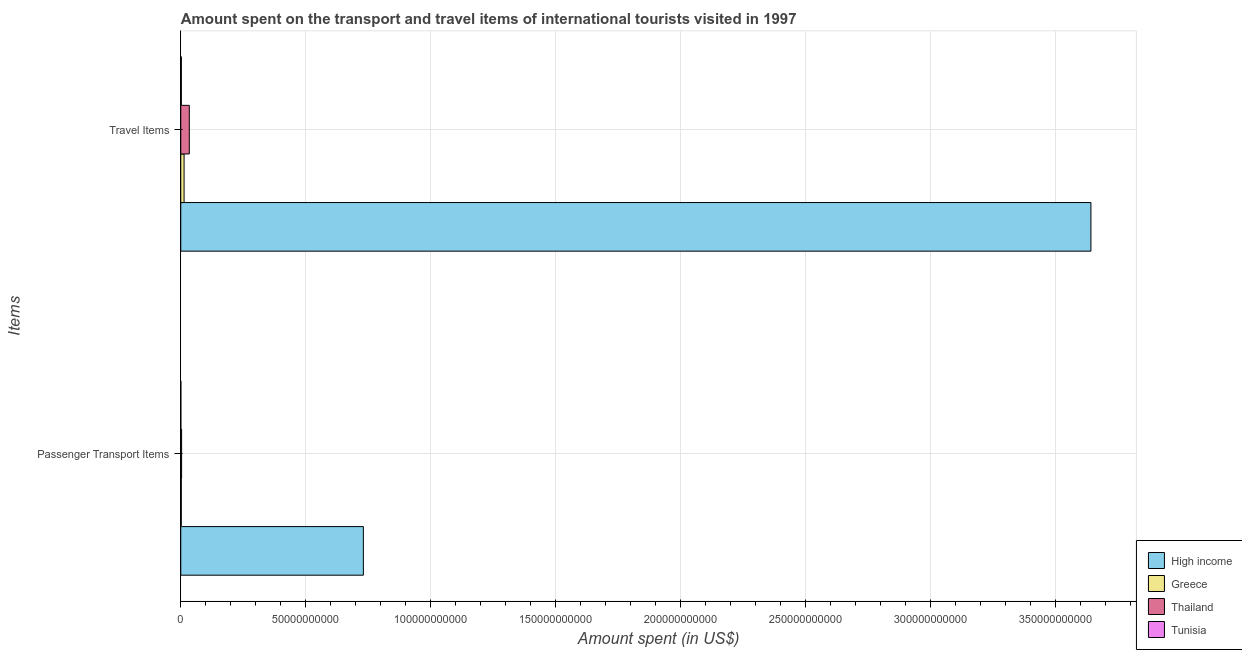Are the number of bars on each tick of the Y-axis equal?
Give a very brief answer. Yes. How many bars are there on the 1st tick from the top?
Your response must be concise. 4. How many bars are there on the 2nd tick from the bottom?
Your answer should be compact. 4. What is the label of the 2nd group of bars from the top?
Ensure brevity in your answer.  Passenger Transport Items. What is the amount spent on passenger transport items in Thailand?
Give a very brief answer. 3.36e+08. Across all countries, what is the maximum amount spent in travel items?
Keep it short and to the point. 3.64e+11. Across all countries, what is the minimum amount spent in travel items?
Your answer should be compact. 2.35e+08. In which country was the amount spent on passenger transport items maximum?
Ensure brevity in your answer.  High income. In which country was the amount spent on passenger transport items minimum?
Your answer should be very brief. Tunisia. What is the total amount spent on passenger transport items in the graph?
Offer a very short reply. 7.36e+1. What is the difference between the amount spent on passenger transport items in Thailand and that in Greece?
Give a very brief answer. 1.26e+08. What is the difference between the amount spent on passenger transport items in Tunisia and the amount spent in travel items in High income?
Keep it short and to the point. -3.64e+11. What is the average amount spent on passenger transport items per country?
Provide a short and direct response. 1.84e+1. What is the difference between the amount spent on passenger transport items and amount spent in travel items in High income?
Your answer should be compact. -2.91e+11. What is the ratio of the amount spent on passenger transport items in Thailand to that in Tunisia?
Provide a short and direct response. 10.84. What does the 1st bar from the top in Travel Items represents?
Keep it short and to the point. Tunisia. How many bars are there?
Ensure brevity in your answer.  8. How many countries are there in the graph?
Offer a terse response. 4. Are the values on the major ticks of X-axis written in scientific E-notation?
Ensure brevity in your answer.  No. Does the graph contain any zero values?
Offer a terse response. No. Does the graph contain grids?
Your response must be concise. Yes. How are the legend labels stacked?
Make the answer very short. Vertical. What is the title of the graph?
Your answer should be very brief. Amount spent on the transport and travel items of international tourists visited in 1997. What is the label or title of the X-axis?
Keep it short and to the point. Amount spent (in US$). What is the label or title of the Y-axis?
Your response must be concise. Items. What is the Amount spent (in US$) in High income in Passenger Transport Items?
Your answer should be compact. 7.31e+1. What is the Amount spent (in US$) in Greece in Passenger Transport Items?
Provide a succinct answer. 2.10e+08. What is the Amount spent (in US$) in Thailand in Passenger Transport Items?
Offer a very short reply. 3.36e+08. What is the Amount spent (in US$) in Tunisia in Passenger Transport Items?
Offer a terse response. 3.10e+07. What is the Amount spent (in US$) in High income in Travel Items?
Make the answer very short. 3.64e+11. What is the Amount spent (in US$) in Greece in Travel Items?
Your response must be concise. 1.33e+09. What is the Amount spent (in US$) in Thailand in Travel Items?
Ensure brevity in your answer.  3.42e+09. What is the Amount spent (in US$) in Tunisia in Travel Items?
Your response must be concise. 2.35e+08. Across all Items, what is the maximum Amount spent (in US$) in High income?
Provide a succinct answer. 3.64e+11. Across all Items, what is the maximum Amount spent (in US$) in Greece?
Ensure brevity in your answer.  1.33e+09. Across all Items, what is the maximum Amount spent (in US$) in Thailand?
Provide a succinct answer. 3.42e+09. Across all Items, what is the maximum Amount spent (in US$) of Tunisia?
Make the answer very short. 2.35e+08. Across all Items, what is the minimum Amount spent (in US$) in High income?
Your response must be concise. 7.31e+1. Across all Items, what is the minimum Amount spent (in US$) in Greece?
Your answer should be compact. 2.10e+08. Across all Items, what is the minimum Amount spent (in US$) in Thailand?
Provide a short and direct response. 3.36e+08. Across all Items, what is the minimum Amount spent (in US$) in Tunisia?
Make the answer very short. 3.10e+07. What is the total Amount spent (in US$) of High income in the graph?
Make the answer very short. 4.37e+11. What is the total Amount spent (in US$) in Greece in the graph?
Give a very brief answer. 1.54e+09. What is the total Amount spent (in US$) in Thailand in the graph?
Provide a short and direct response. 3.75e+09. What is the total Amount spent (in US$) in Tunisia in the graph?
Give a very brief answer. 2.66e+08. What is the difference between the Amount spent (in US$) of High income in Passenger Transport Items and that in Travel Items?
Make the answer very short. -2.91e+11. What is the difference between the Amount spent (in US$) of Greece in Passenger Transport Items and that in Travel Items?
Ensure brevity in your answer.  -1.12e+09. What is the difference between the Amount spent (in US$) in Thailand in Passenger Transport Items and that in Travel Items?
Your answer should be compact. -3.08e+09. What is the difference between the Amount spent (in US$) in Tunisia in Passenger Transport Items and that in Travel Items?
Your answer should be very brief. -2.04e+08. What is the difference between the Amount spent (in US$) of High income in Passenger Transport Items and the Amount spent (in US$) of Greece in Travel Items?
Give a very brief answer. 7.17e+1. What is the difference between the Amount spent (in US$) of High income in Passenger Transport Items and the Amount spent (in US$) of Thailand in Travel Items?
Offer a terse response. 6.96e+1. What is the difference between the Amount spent (in US$) of High income in Passenger Transport Items and the Amount spent (in US$) of Tunisia in Travel Items?
Your answer should be very brief. 7.28e+1. What is the difference between the Amount spent (in US$) of Greece in Passenger Transport Items and the Amount spent (in US$) of Thailand in Travel Items?
Offer a terse response. -3.21e+09. What is the difference between the Amount spent (in US$) in Greece in Passenger Transport Items and the Amount spent (in US$) in Tunisia in Travel Items?
Your response must be concise. -2.50e+07. What is the difference between the Amount spent (in US$) of Thailand in Passenger Transport Items and the Amount spent (in US$) of Tunisia in Travel Items?
Your answer should be very brief. 1.01e+08. What is the average Amount spent (in US$) in High income per Items?
Your answer should be compact. 2.19e+11. What is the average Amount spent (in US$) of Greece per Items?
Give a very brief answer. 7.68e+08. What is the average Amount spent (in US$) in Thailand per Items?
Your answer should be compact. 1.88e+09. What is the average Amount spent (in US$) of Tunisia per Items?
Your answer should be very brief. 1.33e+08. What is the difference between the Amount spent (in US$) of High income and Amount spent (in US$) of Greece in Passenger Transport Items?
Give a very brief answer. 7.28e+1. What is the difference between the Amount spent (in US$) of High income and Amount spent (in US$) of Thailand in Passenger Transport Items?
Your answer should be very brief. 7.27e+1. What is the difference between the Amount spent (in US$) of High income and Amount spent (in US$) of Tunisia in Passenger Transport Items?
Offer a very short reply. 7.30e+1. What is the difference between the Amount spent (in US$) of Greece and Amount spent (in US$) of Thailand in Passenger Transport Items?
Your answer should be compact. -1.26e+08. What is the difference between the Amount spent (in US$) of Greece and Amount spent (in US$) of Tunisia in Passenger Transport Items?
Ensure brevity in your answer.  1.79e+08. What is the difference between the Amount spent (in US$) in Thailand and Amount spent (in US$) in Tunisia in Passenger Transport Items?
Offer a terse response. 3.05e+08. What is the difference between the Amount spent (in US$) in High income and Amount spent (in US$) in Greece in Travel Items?
Offer a very short reply. 3.63e+11. What is the difference between the Amount spent (in US$) of High income and Amount spent (in US$) of Thailand in Travel Items?
Give a very brief answer. 3.61e+11. What is the difference between the Amount spent (in US$) of High income and Amount spent (in US$) of Tunisia in Travel Items?
Provide a succinct answer. 3.64e+11. What is the difference between the Amount spent (in US$) in Greece and Amount spent (in US$) in Thailand in Travel Items?
Make the answer very short. -2.09e+09. What is the difference between the Amount spent (in US$) in Greece and Amount spent (in US$) in Tunisia in Travel Items?
Keep it short and to the point. 1.09e+09. What is the difference between the Amount spent (in US$) in Thailand and Amount spent (in US$) in Tunisia in Travel Items?
Make the answer very short. 3.18e+09. What is the ratio of the Amount spent (in US$) of High income in Passenger Transport Items to that in Travel Items?
Provide a succinct answer. 0.2. What is the ratio of the Amount spent (in US$) of Greece in Passenger Transport Items to that in Travel Items?
Keep it short and to the point. 0.16. What is the ratio of the Amount spent (in US$) of Thailand in Passenger Transport Items to that in Travel Items?
Your answer should be very brief. 0.1. What is the ratio of the Amount spent (in US$) in Tunisia in Passenger Transport Items to that in Travel Items?
Provide a succinct answer. 0.13. What is the difference between the highest and the second highest Amount spent (in US$) of High income?
Offer a very short reply. 2.91e+11. What is the difference between the highest and the second highest Amount spent (in US$) of Greece?
Offer a terse response. 1.12e+09. What is the difference between the highest and the second highest Amount spent (in US$) in Thailand?
Offer a terse response. 3.08e+09. What is the difference between the highest and the second highest Amount spent (in US$) of Tunisia?
Your response must be concise. 2.04e+08. What is the difference between the highest and the lowest Amount spent (in US$) in High income?
Give a very brief answer. 2.91e+11. What is the difference between the highest and the lowest Amount spent (in US$) in Greece?
Your answer should be very brief. 1.12e+09. What is the difference between the highest and the lowest Amount spent (in US$) in Thailand?
Ensure brevity in your answer.  3.08e+09. What is the difference between the highest and the lowest Amount spent (in US$) of Tunisia?
Your answer should be compact. 2.04e+08. 